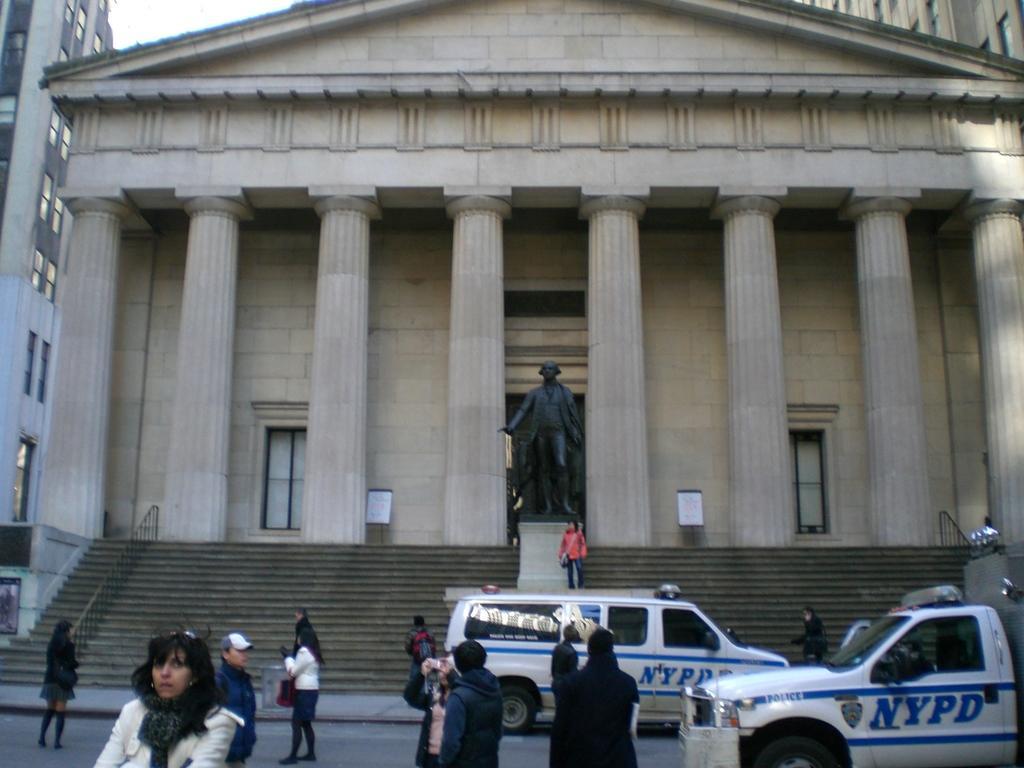How would you summarize this image in a sentence or two? There are people, vehicles, stairs and a sculpture. There are buildings which has pillars, windows and a door. 